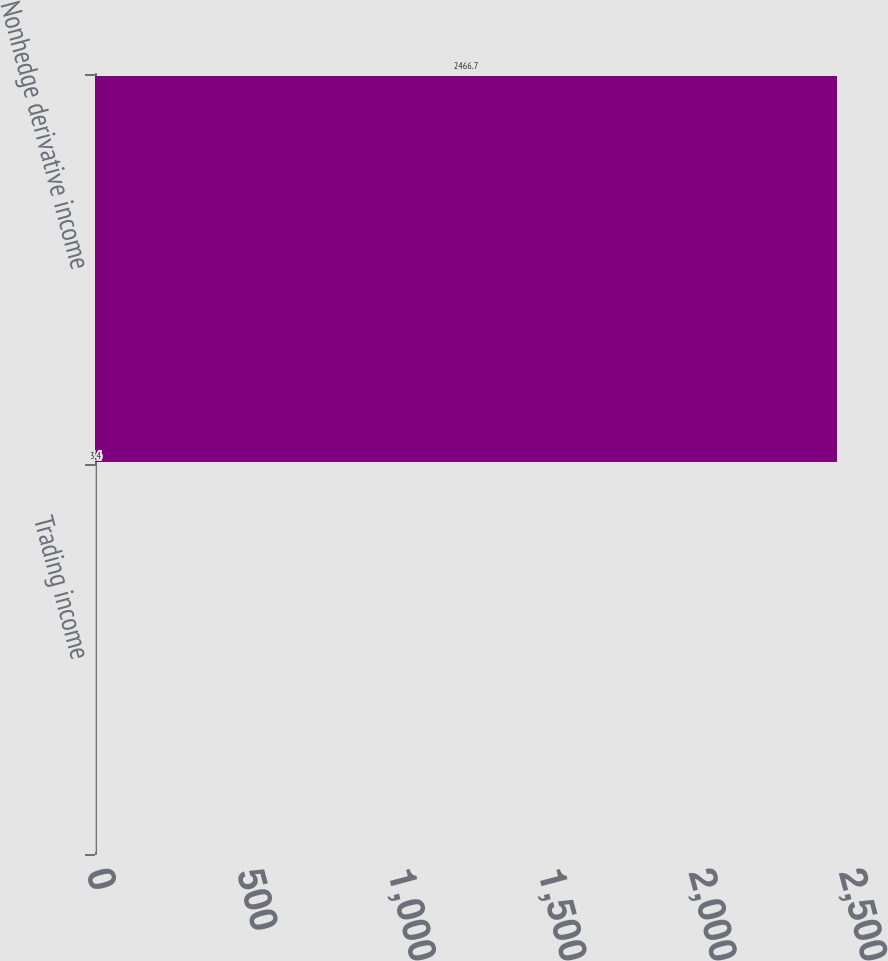<chart> <loc_0><loc_0><loc_500><loc_500><bar_chart><fcel>Trading income<fcel>Nonhedge derivative income<nl><fcel>3.4<fcel>2466.7<nl></chart> 